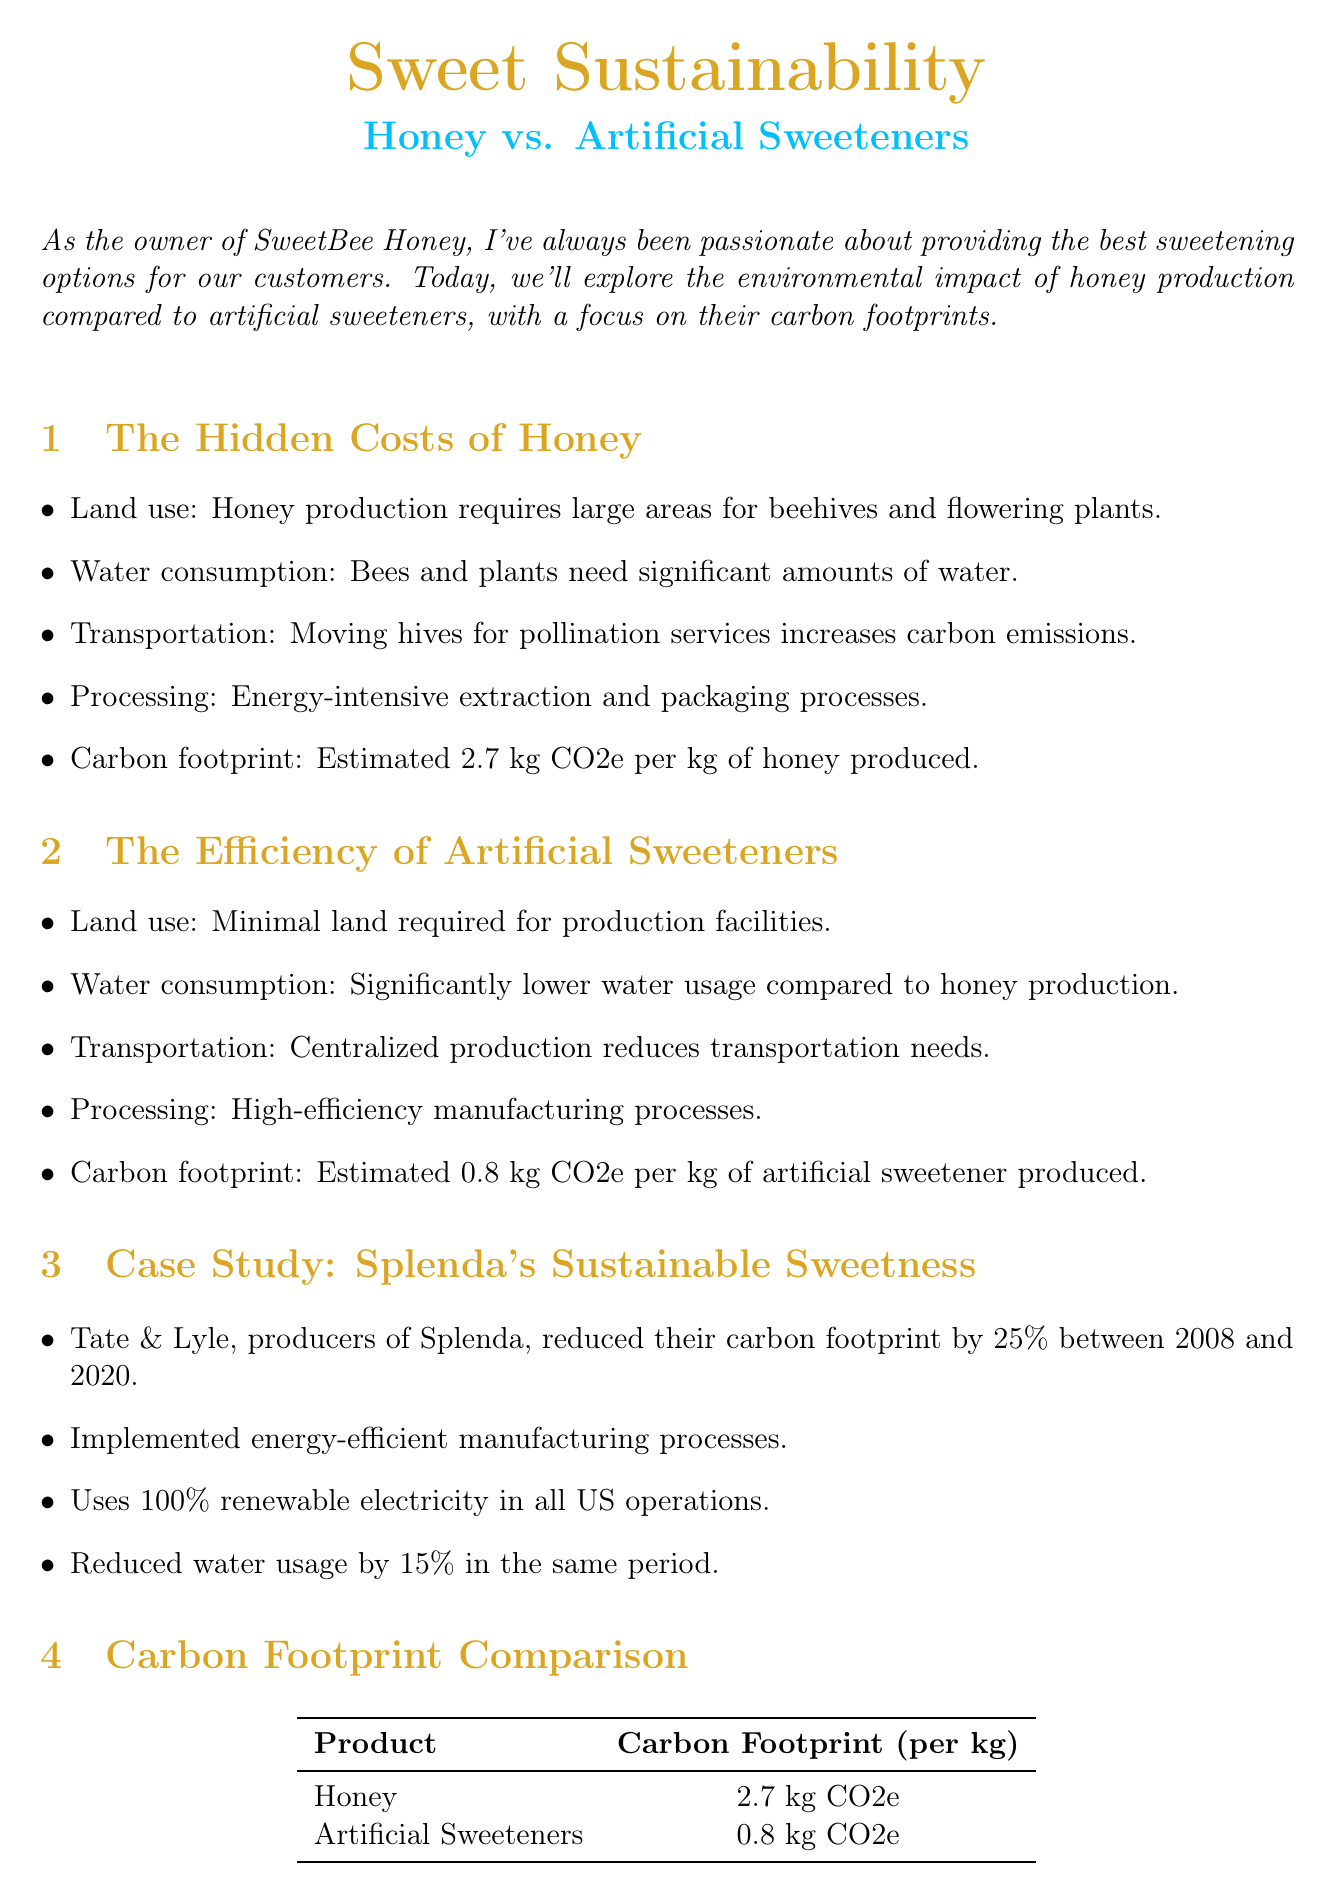What is the estimated carbon footprint of honey production? The carbon footprint for honey production is stated in the document as 2.7 kg CO2e per kg of honey produced.
Answer: 2.7 kg CO2e What is the estimated carbon footprint of artificial sweeteners? The document lists the carbon footprint for artificial sweeteners as 0.8 kg CO2e per kg of artificial sweetener produced.
Answer: 0.8 kg CO2e Who is the expert quoted in the newsletter? The document mentions an expert opinion from Dr. Emily Green, providing her title along with her quote regarding the environmental impact of honey vs. artificial sweeteners.
Answer: Dr. Emily Green What company is partnering with SweetBee to source environmentally friendly sweeteners? The partnership mentioned in the document is with Cargill for sourcing environmentally friendly sweeteners.
Answer: Cargill What new product line is SweetBee introducing? The document introduces a new line of artificial sweeteners named NaturSweet.
Answer: NaturSweet By how much did Tate & Lyle reduce their carbon footprint between 2008 and 2020? The document states that Tate & Lyle decreased their carbon footprint by 25% during that period.
Answer: 25% What are the water usage levels in honey production compared to artificial sweeteners? The document indicates that artificial sweeteners have significantly lower water usage compared to honey production.
Answer: Significantly lower What is the key message of the newsletter? The key message is that artificial sweeteners offer a more sustainable alternative to traditional honey production, as stated in the introduction.
Answer: Artificial sweeteners offer a more sustainable alternative 